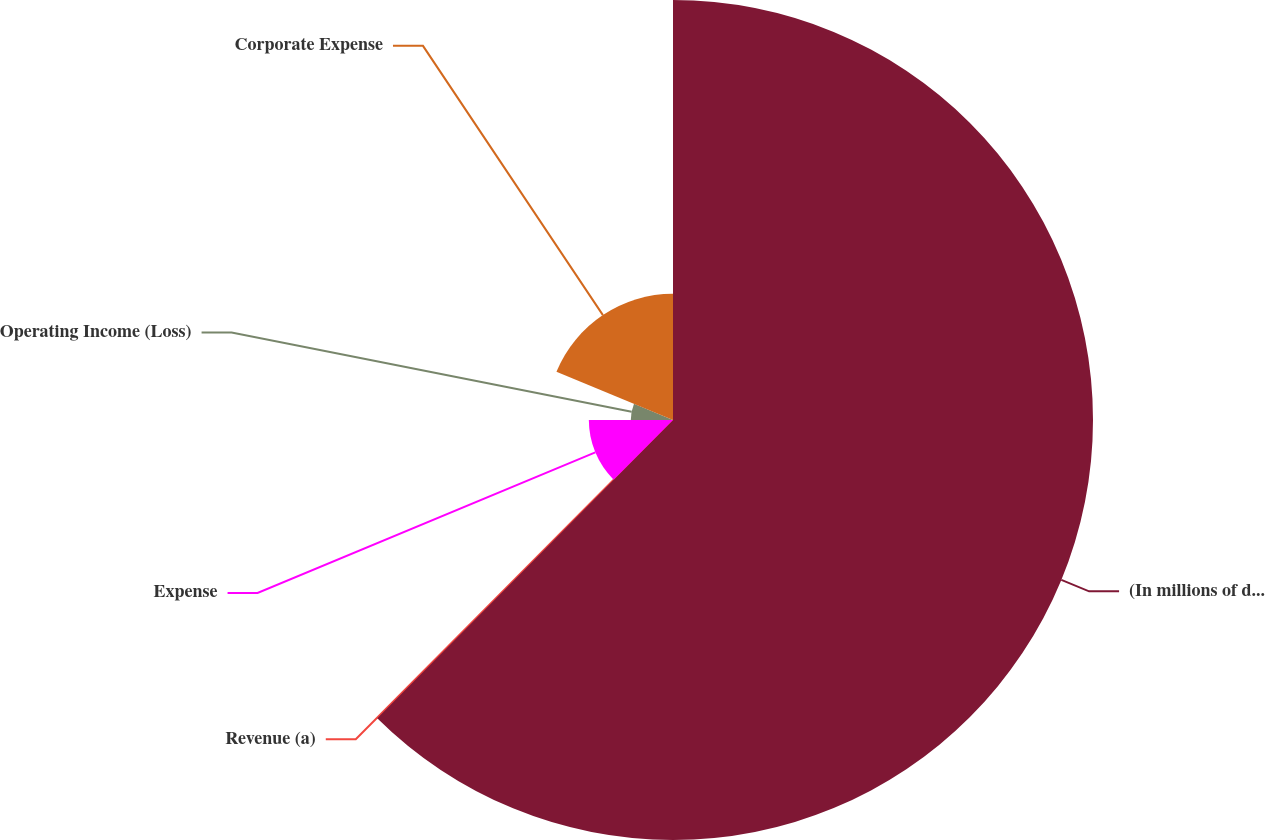Convert chart to OTSL. <chart><loc_0><loc_0><loc_500><loc_500><pie_chart><fcel>(In millions of dollars)<fcel>Revenue (a)<fcel>Expense<fcel>Operating Income (Loss)<fcel>Corporate Expense<nl><fcel>62.43%<fcel>0.03%<fcel>12.51%<fcel>6.27%<fcel>18.75%<nl></chart> 